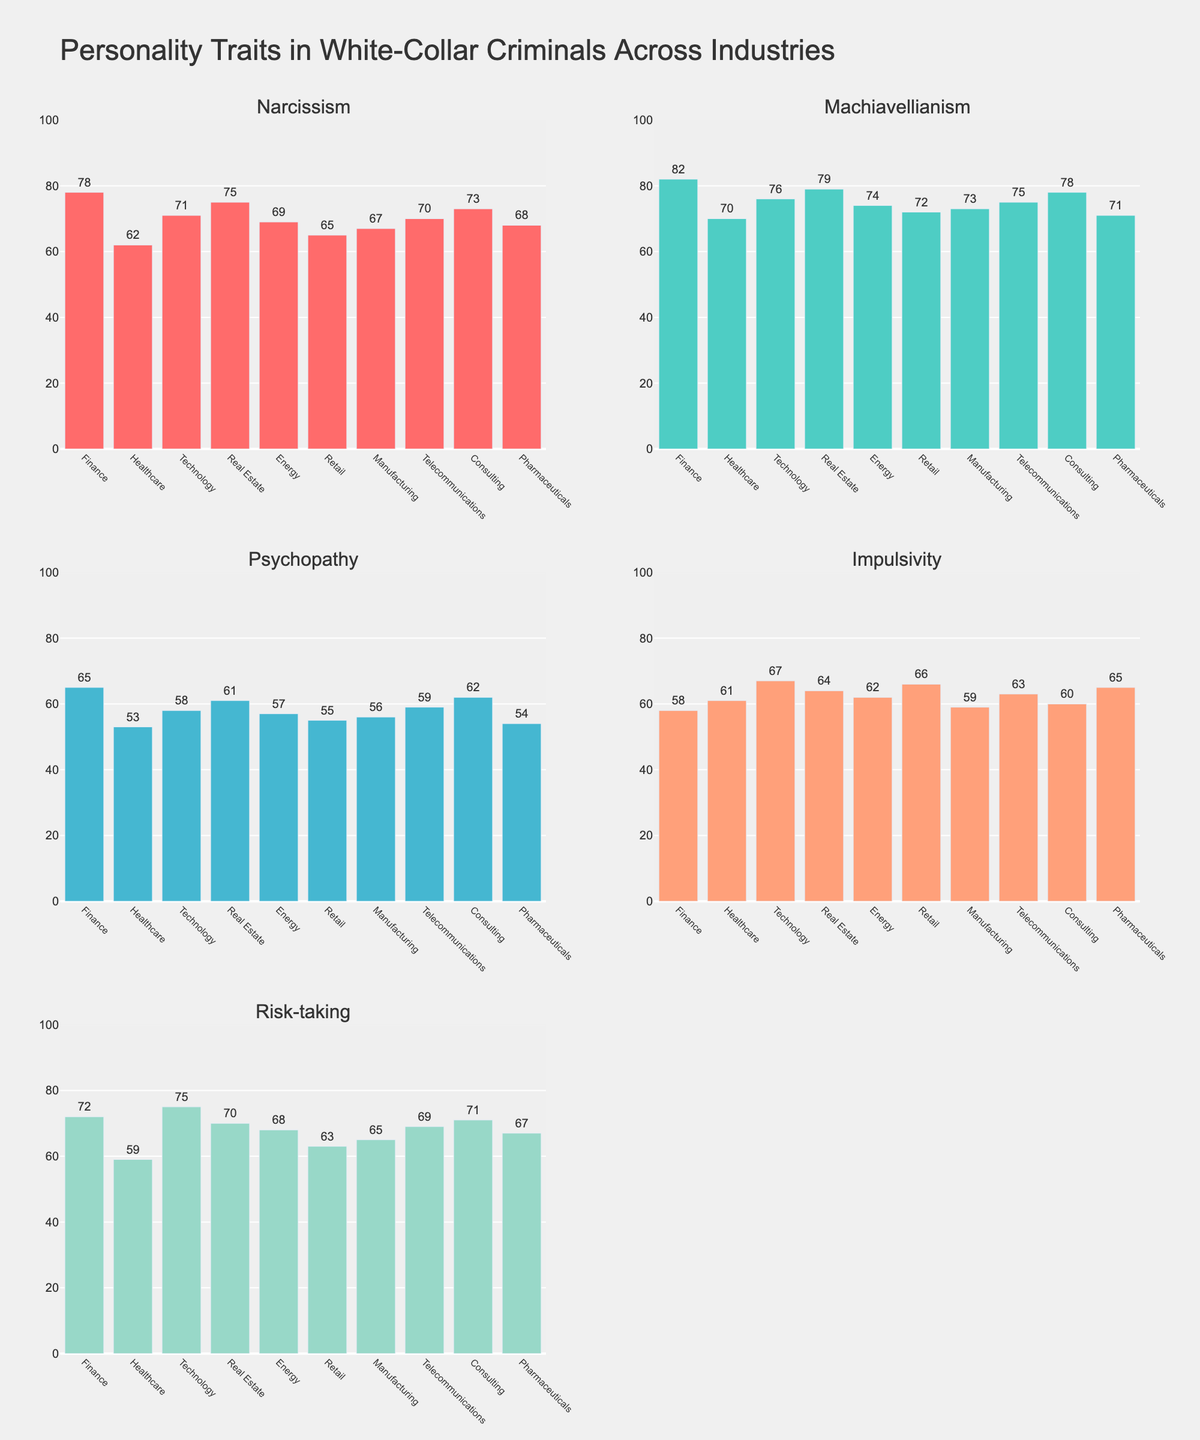How many different crops are shown in the figure? There are five different crops shown in the figure: Maize, Cassava, Yams, Millet, and Sorghum. Each subplot contains bars representing these five crops.
Answer: Five Which year had the highest yield for Maize? To determine which year had the highest yield for Maize, look at the heights of the Maize bars in each subplot. The tallest Maize bar is in the 2022 subplot with a yield of 3500.
Answer: 2022 What is the average yield of Cassava over the years? The yield of Cassava for each year is as follows: 2019 (4500), 2020 (4300), 2021 (4700), and 2022 (4600). To find the average, sum these values and divide by 4. (4500 + 4300 + 4700 + 4600) / 4 = 4562.5.
Answer: 4562.5 Which crop had the lowest yield in 2019? In the 2019 subplot, the shortest bar belongs to Millet with a yield of 1900.
Answer: Millet Compare the yield of Yams in 2020 and 2022. Which year had a higher yield? In the 2020 subplot, the yield of Yams is 3000. In the 2022 subplot, the yield of Yams is 3200. Thus, 2022 had a higher yield for Yams than 2020.
Answer: 2022 What is the total yield of all crops in 2021? The yields of the five crops in 2021 are Maize (3100), Cassava (4700), Yams (2600), Millet (1800), and Sorghum (2300). Sum these values to get the total yield: 3100 + 4700 + 2600 + 1800 + 2300 = 14500.
Answer: 14500 How does the yield of Sorghum change from 2019 to 2022? The yields of Sorghum for the years are as follows: 2019 (2100), 2020 (2200), 2021 (2300), and 2022 (2400). Observing the trend shows that the yield increases each year by 100 units.
Answer: It increased each year Which year shows the most balanced yields across all crops? A balanced yield means that the bars have similar heights. By visually inspecting the subplots, 2020 and 2022 have relatively balanced yields. However, 2020 has less variation in bar heights than 2022.
Answer: 2020 What is the difference between the highest and lowest yield for Yams across the four years? The yields for Yams over the years are: 2019 (2800), 2020 (3000), 2021 (2600), 2022 (3200). The highest yield is 3200 (2022) and the lowest yield is 2600 (2021). The difference is 3200 - 2600 = 600.
Answer: 600 